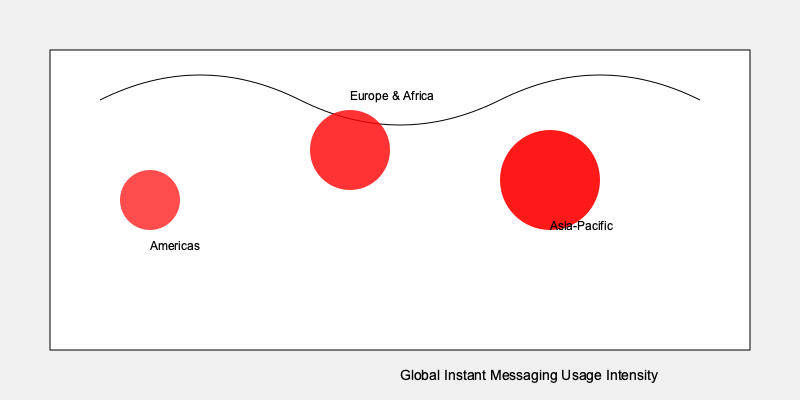Based on the heat map of global instant messaging usage, which region shows the highest intensity of usage, and what factors might contribute to this pattern in the context of social interactions research? To answer this question, we need to analyze the heat map and consider the implications for social interactions research:

1. Examine the heat map:
   - The map shows three main regions: Americas, Europe & Africa, and Asia-Pacific.
   - The intensity of usage is represented by the size and opacity of the red circles.

2. Identify the region with the highest intensity:
   - The Asia-Pacific region has the largest and most opaque red circle, indicating the highest usage intensity.

3. Consider factors contributing to this pattern:
   a) Population density: Asia-Pacific has some of the world's most populous countries, which could lead to more users and higher usage intensity.
   b) Technological infrastructure: Many Asian countries have advanced mobile networks, facilitating widespread adoption of instant messaging apps.
   c) Cultural factors: Collectivist cultures in Asia may emphasize constant communication and group interactions.
   d) Economic factors: The prevalence of affordable smartphones and data plans in many Asian countries could contribute to higher usage.
   e) Social norms: In some Asian societies, instant messaging may be the preferred method of communication for both personal and professional interactions.

4. Relevance to social interactions research:
   - This pattern suggests that studying instant messaging usage in the Asia-Pacific region could provide rich data on how digital communication impacts social dynamics.
   - Researchers could investigate how the high intensity of usage affects face-to-face interactions, social capital, and cultural practices in these societies.
   - Comparative studies between regions could reveal how different levels of instant messaging usage correlate with various aspects of social behavior and relationship formation.
Answer: Asia-Pacific; factors include population density, technological infrastructure, cultural preferences, economic accessibility, and social norms favoring digital communication. 